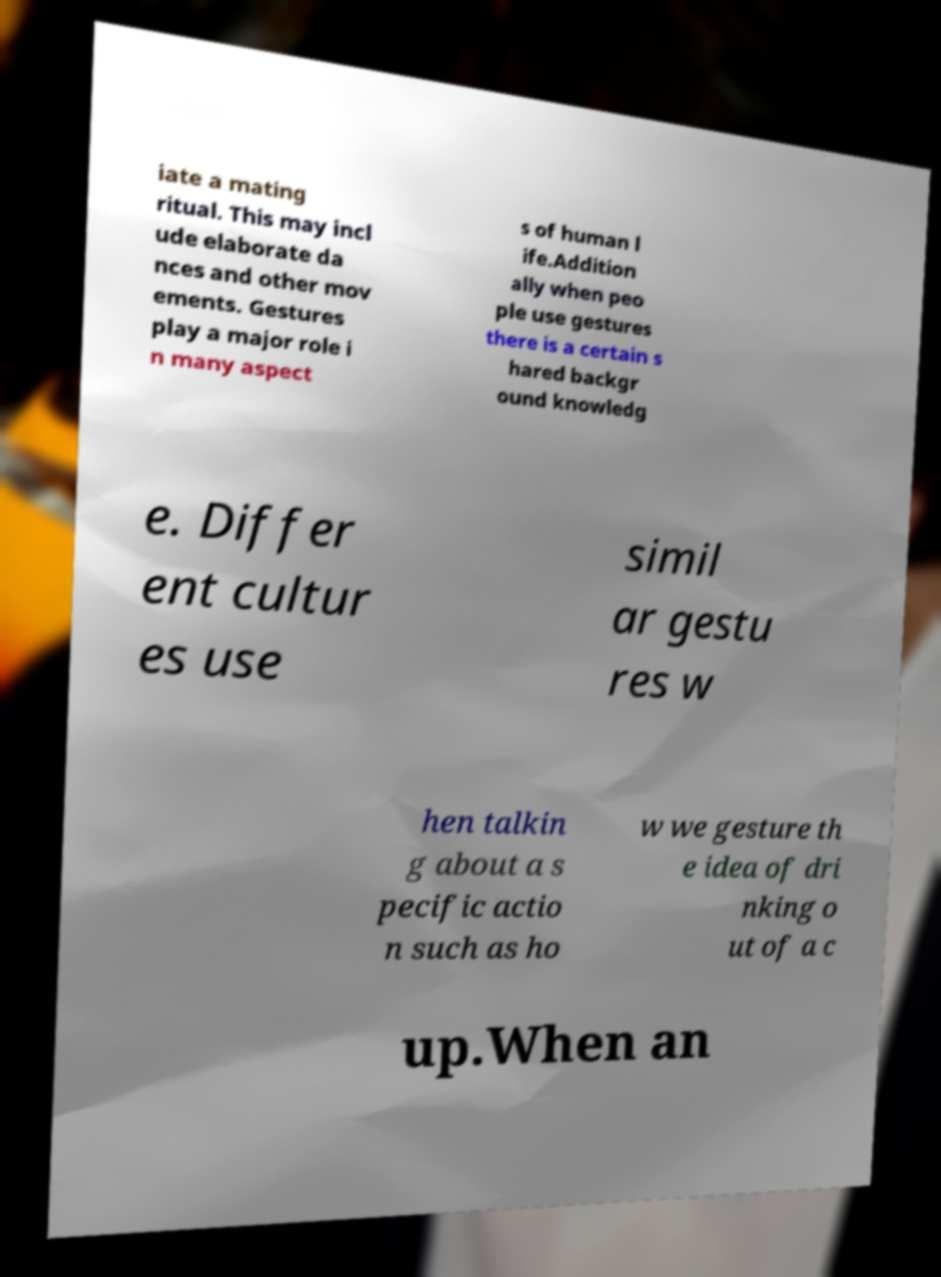Could you assist in decoding the text presented in this image and type it out clearly? iate a mating ritual. This may incl ude elaborate da nces and other mov ements. Gestures play a major role i n many aspect s of human l ife.Addition ally when peo ple use gestures there is a certain s hared backgr ound knowledg e. Differ ent cultur es use simil ar gestu res w hen talkin g about a s pecific actio n such as ho w we gesture th e idea of dri nking o ut of a c up.When an 